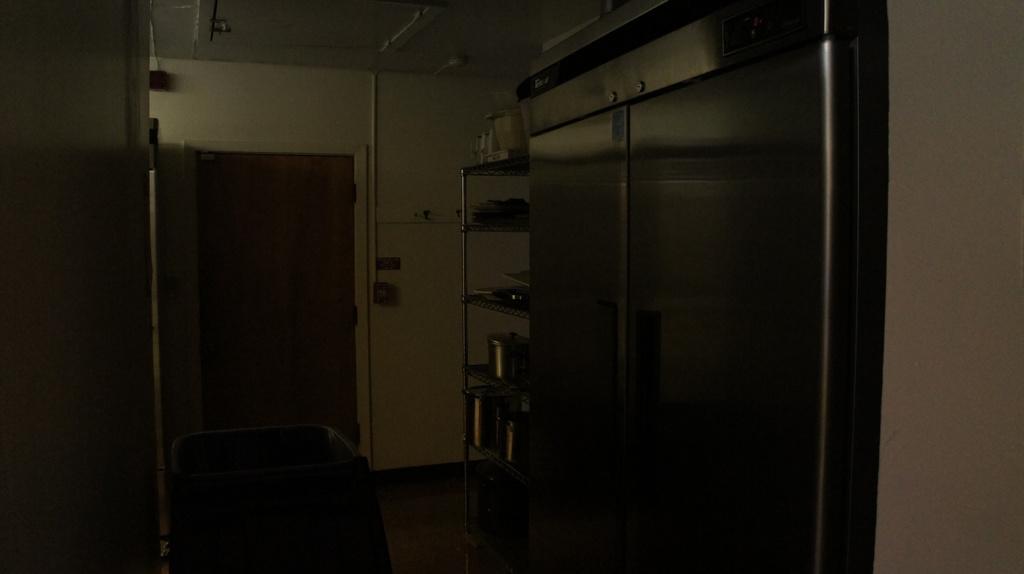How would you summarize this image in a sentence or two? In this picture I can see some objects in a rack, it looks like a refrigerator, there is a door and there are some objects, and in the background there is a wall. 